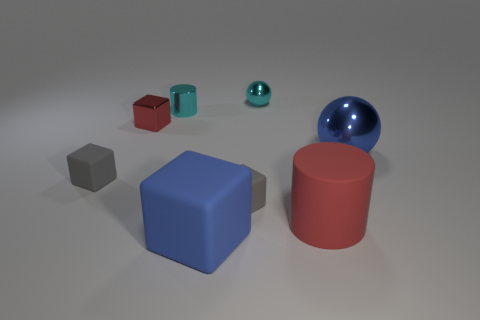Subtract all large rubber blocks. How many blocks are left? 3 Subtract all blue cylinders. How many gray cubes are left? 2 Add 2 large red matte cylinders. How many objects exist? 10 Subtract all blue blocks. How many blocks are left? 3 Subtract all blue cubes. Subtract all brown cylinders. How many cubes are left? 3 Subtract all cylinders. How many objects are left? 6 Add 5 tiny gray matte cubes. How many tiny gray matte cubes exist? 7 Subtract 0 blue cylinders. How many objects are left? 8 Subtract all big green metallic objects. Subtract all tiny shiny cylinders. How many objects are left? 7 Add 1 large blue matte things. How many large blue matte things are left? 2 